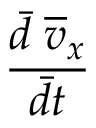<formula> <loc_0><loc_0><loc_500><loc_500>\frac { \ B a r { d } \, \overline { v } _ { x } } { \ B a r { d t } }</formula> 